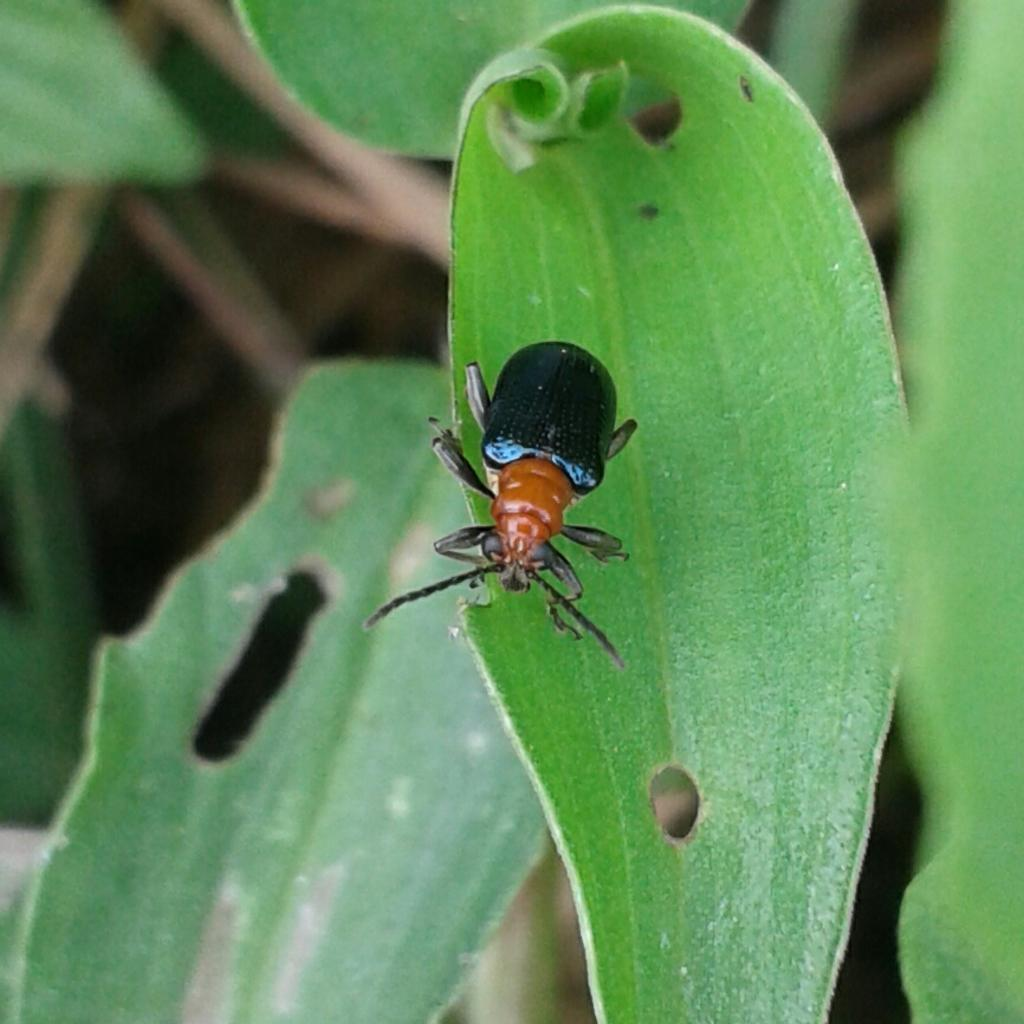What is present in the image? There is an insect in the image. Where is the insect located? The insect is on a leaf. What type of acoustics can be heard from the insect in the image? There is no sound or acoustics associated with the insect in the image, as it is a still image. What type of suit is the insect wearing in the image? There is no suit present in the image, as insects do not wear clothing. 